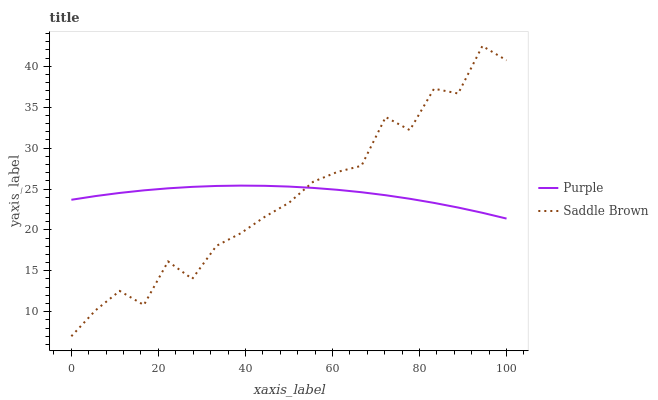Does Saddle Brown have the minimum area under the curve?
Answer yes or no. Yes. Does Purple have the maximum area under the curve?
Answer yes or no. Yes. Does Saddle Brown have the maximum area under the curve?
Answer yes or no. No. Is Purple the smoothest?
Answer yes or no. Yes. Is Saddle Brown the roughest?
Answer yes or no. Yes. Is Saddle Brown the smoothest?
Answer yes or no. No. Does Saddle Brown have the lowest value?
Answer yes or no. Yes. Does Saddle Brown have the highest value?
Answer yes or no. Yes. Does Saddle Brown intersect Purple?
Answer yes or no. Yes. Is Saddle Brown less than Purple?
Answer yes or no. No. Is Saddle Brown greater than Purple?
Answer yes or no. No. 